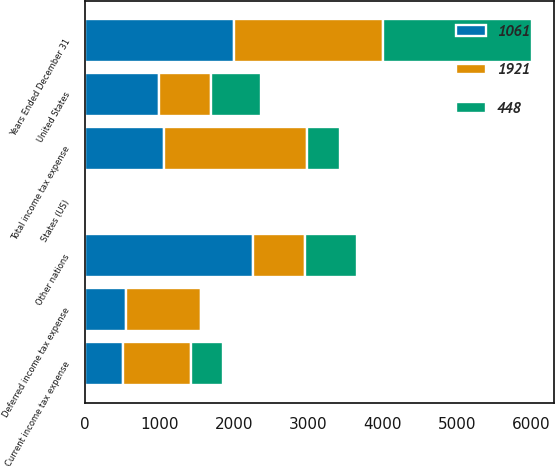<chart> <loc_0><loc_0><loc_500><loc_500><stacked_bar_chart><ecel><fcel>Years Ended December 31<fcel>United States<fcel>Other nations<fcel>States (US)<fcel>Current income tax expense<fcel>Deferred income tax expense<fcel>Total income tax expense<nl><fcel>1921<fcel>2005<fcel>697<fcel>697<fcel>19<fcel>921<fcel>1000<fcel>1921<nl><fcel>1061<fcel>2004<fcel>994<fcel>2258<fcel>6<fcel>506<fcel>555<fcel>1061<nl><fcel>448<fcel>2003<fcel>679<fcel>697<fcel>16<fcel>431<fcel>17<fcel>448<nl></chart> 